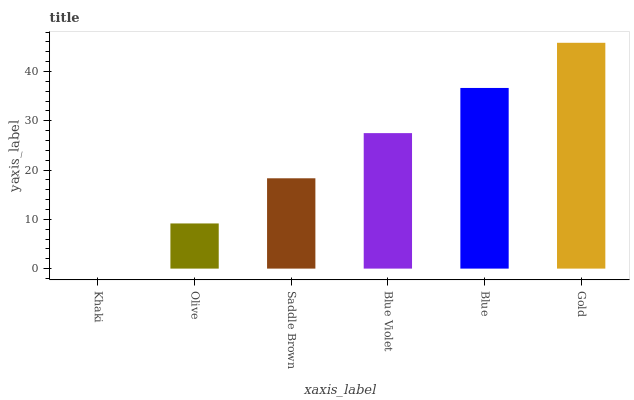Is Khaki the minimum?
Answer yes or no. Yes. Is Gold the maximum?
Answer yes or no. Yes. Is Olive the minimum?
Answer yes or no. No. Is Olive the maximum?
Answer yes or no. No. Is Olive greater than Khaki?
Answer yes or no. Yes. Is Khaki less than Olive?
Answer yes or no. Yes. Is Khaki greater than Olive?
Answer yes or no. No. Is Olive less than Khaki?
Answer yes or no. No. Is Blue Violet the high median?
Answer yes or no. Yes. Is Saddle Brown the low median?
Answer yes or no. Yes. Is Olive the high median?
Answer yes or no. No. Is Gold the low median?
Answer yes or no. No. 